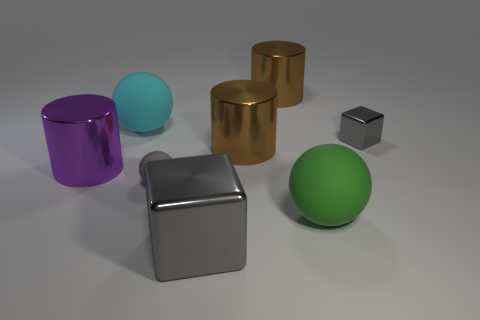Subtract all tiny gray rubber balls. How many balls are left? 2 Subtract all brown cubes. How many brown cylinders are left? 2 Subtract all cyan balls. How many balls are left? 2 Subtract 1 balls. How many balls are left? 2 Add 1 big green things. How many objects exist? 9 Subtract 0 yellow blocks. How many objects are left? 8 Subtract all cylinders. How many objects are left? 5 Subtract all red cylinders. Subtract all blue cubes. How many cylinders are left? 3 Subtract all tiny blocks. Subtract all large cyan matte objects. How many objects are left? 6 Add 4 purple cylinders. How many purple cylinders are left? 5 